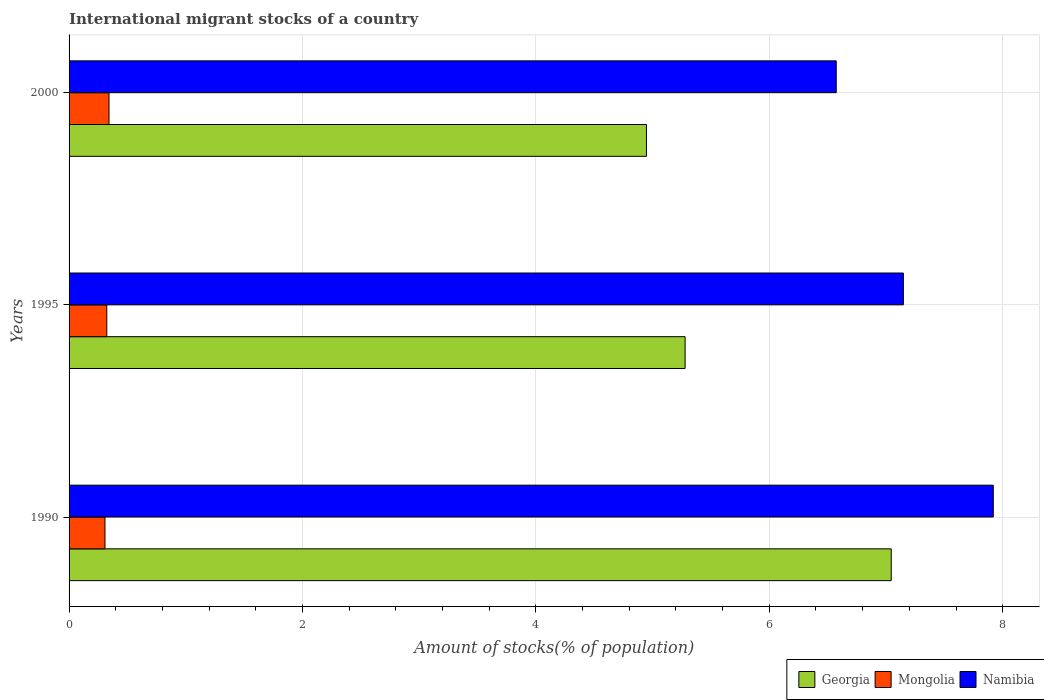Are the number of bars per tick equal to the number of legend labels?
Your answer should be compact. Yes. How many bars are there on the 2nd tick from the top?
Your response must be concise. 3. What is the amount of stocks in in Mongolia in 1990?
Keep it short and to the point. 0.31. Across all years, what is the maximum amount of stocks in in Georgia?
Provide a short and direct response. 7.04. Across all years, what is the minimum amount of stocks in in Georgia?
Provide a short and direct response. 4.95. In which year was the amount of stocks in in Namibia minimum?
Provide a short and direct response. 2000. What is the total amount of stocks in in Namibia in the graph?
Provide a succinct answer. 21.64. What is the difference between the amount of stocks in in Mongolia in 1990 and that in 1995?
Provide a succinct answer. -0.02. What is the difference between the amount of stocks in in Mongolia in 2000 and the amount of stocks in in Namibia in 1995?
Keep it short and to the point. -6.81. What is the average amount of stocks in in Mongolia per year?
Offer a very short reply. 0.32. In the year 1995, what is the difference between the amount of stocks in in Namibia and amount of stocks in in Georgia?
Ensure brevity in your answer.  1.87. What is the ratio of the amount of stocks in in Mongolia in 1995 to that in 2000?
Give a very brief answer. 0.94. Is the amount of stocks in in Namibia in 1990 less than that in 1995?
Keep it short and to the point. No. What is the difference between the highest and the second highest amount of stocks in in Mongolia?
Offer a terse response. 0.02. What is the difference between the highest and the lowest amount of stocks in in Mongolia?
Give a very brief answer. 0.03. What does the 1st bar from the top in 1990 represents?
Your answer should be compact. Namibia. What does the 2nd bar from the bottom in 1990 represents?
Your answer should be very brief. Mongolia. How many bars are there?
Your response must be concise. 9. Are all the bars in the graph horizontal?
Your response must be concise. Yes. What is the difference between two consecutive major ticks on the X-axis?
Your answer should be compact. 2. Are the values on the major ticks of X-axis written in scientific E-notation?
Provide a succinct answer. No. Does the graph contain grids?
Offer a very short reply. Yes. How are the legend labels stacked?
Offer a terse response. Horizontal. What is the title of the graph?
Make the answer very short. International migrant stocks of a country. What is the label or title of the X-axis?
Give a very brief answer. Amount of stocks(% of population). What is the Amount of stocks(% of population) of Georgia in 1990?
Offer a very short reply. 7.04. What is the Amount of stocks(% of population) of Mongolia in 1990?
Your response must be concise. 0.31. What is the Amount of stocks(% of population) in Namibia in 1990?
Give a very brief answer. 7.92. What is the Amount of stocks(% of population) of Georgia in 1995?
Your response must be concise. 5.28. What is the Amount of stocks(% of population) of Mongolia in 1995?
Make the answer very short. 0.32. What is the Amount of stocks(% of population) in Namibia in 1995?
Your response must be concise. 7.15. What is the Amount of stocks(% of population) in Georgia in 2000?
Your response must be concise. 4.95. What is the Amount of stocks(% of population) of Mongolia in 2000?
Keep it short and to the point. 0.34. What is the Amount of stocks(% of population) of Namibia in 2000?
Your answer should be very brief. 6.57. Across all years, what is the maximum Amount of stocks(% of population) in Georgia?
Offer a very short reply. 7.04. Across all years, what is the maximum Amount of stocks(% of population) in Mongolia?
Offer a terse response. 0.34. Across all years, what is the maximum Amount of stocks(% of population) in Namibia?
Ensure brevity in your answer.  7.92. Across all years, what is the minimum Amount of stocks(% of population) of Georgia?
Provide a succinct answer. 4.95. Across all years, what is the minimum Amount of stocks(% of population) in Mongolia?
Keep it short and to the point. 0.31. Across all years, what is the minimum Amount of stocks(% of population) of Namibia?
Offer a terse response. 6.57. What is the total Amount of stocks(% of population) in Georgia in the graph?
Give a very brief answer. 17.27. What is the total Amount of stocks(% of population) of Namibia in the graph?
Your response must be concise. 21.64. What is the difference between the Amount of stocks(% of population) of Georgia in 1990 and that in 1995?
Make the answer very short. 1.77. What is the difference between the Amount of stocks(% of population) of Mongolia in 1990 and that in 1995?
Provide a succinct answer. -0.02. What is the difference between the Amount of stocks(% of population) in Namibia in 1990 and that in 1995?
Your answer should be compact. 0.77. What is the difference between the Amount of stocks(% of population) of Georgia in 1990 and that in 2000?
Offer a terse response. 2.1. What is the difference between the Amount of stocks(% of population) in Mongolia in 1990 and that in 2000?
Provide a succinct answer. -0.03. What is the difference between the Amount of stocks(% of population) in Namibia in 1990 and that in 2000?
Make the answer very short. 1.35. What is the difference between the Amount of stocks(% of population) in Georgia in 1995 and that in 2000?
Offer a terse response. 0.33. What is the difference between the Amount of stocks(% of population) in Mongolia in 1995 and that in 2000?
Provide a short and direct response. -0.02. What is the difference between the Amount of stocks(% of population) of Namibia in 1995 and that in 2000?
Your response must be concise. 0.58. What is the difference between the Amount of stocks(% of population) in Georgia in 1990 and the Amount of stocks(% of population) in Mongolia in 1995?
Your response must be concise. 6.72. What is the difference between the Amount of stocks(% of population) of Georgia in 1990 and the Amount of stocks(% of population) of Namibia in 1995?
Provide a short and direct response. -0.1. What is the difference between the Amount of stocks(% of population) in Mongolia in 1990 and the Amount of stocks(% of population) in Namibia in 1995?
Provide a short and direct response. -6.84. What is the difference between the Amount of stocks(% of population) of Georgia in 1990 and the Amount of stocks(% of population) of Mongolia in 2000?
Your response must be concise. 6.7. What is the difference between the Amount of stocks(% of population) in Georgia in 1990 and the Amount of stocks(% of population) in Namibia in 2000?
Offer a terse response. 0.47. What is the difference between the Amount of stocks(% of population) of Mongolia in 1990 and the Amount of stocks(% of population) of Namibia in 2000?
Give a very brief answer. -6.27. What is the difference between the Amount of stocks(% of population) in Georgia in 1995 and the Amount of stocks(% of population) in Mongolia in 2000?
Make the answer very short. 4.94. What is the difference between the Amount of stocks(% of population) in Georgia in 1995 and the Amount of stocks(% of population) in Namibia in 2000?
Give a very brief answer. -1.29. What is the difference between the Amount of stocks(% of population) in Mongolia in 1995 and the Amount of stocks(% of population) in Namibia in 2000?
Give a very brief answer. -6.25. What is the average Amount of stocks(% of population) in Georgia per year?
Keep it short and to the point. 5.76. What is the average Amount of stocks(% of population) in Mongolia per year?
Offer a terse response. 0.32. What is the average Amount of stocks(% of population) in Namibia per year?
Provide a short and direct response. 7.21. In the year 1990, what is the difference between the Amount of stocks(% of population) of Georgia and Amount of stocks(% of population) of Mongolia?
Keep it short and to the point. 6.74. In the year 1990, what is the difference between the Amount of stocks(% of population) in Georgia and Amount of stocks(% of population) in Namibia?
Provide a succinct answer. -0.87. In the year 1990, what is the difference between the Amount of stocks(% of population) in Mongolia and Amount of stocks(% of population) in Namibia?
Make the answer very short. -7.61. In the year 1995, what is the difference between the Amount of stocks(% of population) in Georgia and Amount of stocks(% of population) in Mongolia?
Make the answer very short. 4.96. In the year 1995, what is the difference between the Amount of stocks(% of population) of Georgia and Amount of stocks(% of population) of Namibia?
Ensure brevity in your answer.  -1.87. In the year 1995, what is the difference between the Amount of stocks(% of population) of Mongolia and Amount of stocks(% of population) of Namibia?
Your response must be concise. -6.83. In the year 2000, what is the difference between the Amount of stocks(% of population) of Georgia and Amount of stocks(% of population) of Mongolia?
Your response must be concise. 4.61. In the year 2000, what is the difference between the Amount of stocks(% of population) of Georgia and Amount of stocks(% of population) of Namibia?
Ensure brevity in your answer.  -1.63. In the year 2000, what is the difference between the Amount of stocks(% of population) of Mongolia and Amount of stocks(% of population) of Namibia?
Ensure brevity in your answer.  -6.23. What is the ratio of the Amount of stocks(% of population) of Georgia in 1990 to that in 1995?
Your answer should be compact. 1.33. What is the ratio of the Amount of stocks(% of population) in Mongolia in 1990 to that in 1995?
Offer a very short reply. 0.95. What is the ratio of the Amount of stocks(% of population) of Namibia in 1990 to that in 1995?
Your answer should be very brief. 1.11. What is the ratio of the Amount of stocks(% of population) of Georgia in 1990 to that in 2000?
Give a very brief answer. 1.42. What is the ratio of the Amount of stocks(% of population) in Mongolia in 1990 to that in 2000?
Your answer should be very brief. 0.9. What is the ratio of the Amount of stocks(% of population) of Namibia in 1990 to that in 2000?
Your answer should be very brief. 1.2. What is the ratio of the Amount of stocks(% of population) in Georgia in 1995 to that in 2000?
Your answer should be very brief. 1.07. What is the ratio of the Amount of stocks(% of population) in Mongolia in 1995 to that in 2000?
Your answer should be very brief. 0.94. What is the ratio of the Amount of stocks(% of population) in Namibia in 1995 to that in 2000?
Offer a very short reply. 1.09. What is the difference between the highest and the second highest Amount of stocks(% of population) in Georgia?
Offer a terse response. 1.77. What is the difference between the highest and the second highest Amount of stocks(% of population) in Mongolia?
Give a very brief answer. 0.02. What is the difference between the highest and the second highest Amount of stocks(% of population) in Namibia?
Your answer should be very brief. 0.77. What is the difference between the highest and the lowest Amount of stocks(% of population) of Georgia?
Ensure brevity in your answer.  2.1. What is the difference between the highest and the lowest Amount of stocks(% of population) in Mongolia?
Give a very brief answer. 0.03. What is the difference between the highest and the lowest Amount of stocks(% of population) of Namibia?
Ensure brevity in your answer.  1.35. 